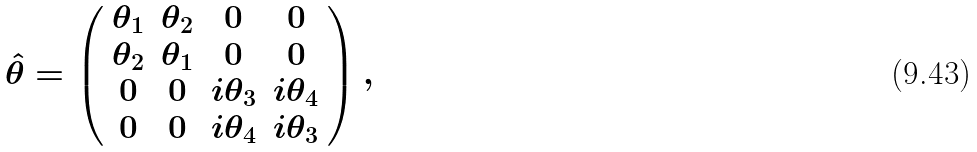Convert formula to latex. <formula><loc_0><loc_0><loc_500><loc_500>\hat { \theta } = \left ( \begin{array} { c c c c } \theta _ { 1 } & \theta _ { 2 } & 0 & 0 \\ \theta _ { 2 } & \theta _ { 1 } & 0 & 0 \\ 0 & 0 & i \theta _ { 3 } & i \theta _ { 4 } \\ 0 & 0 & i \theta _ { 4 } & i \theta _ { 3 } \end{array} \right ) ,</formula> 